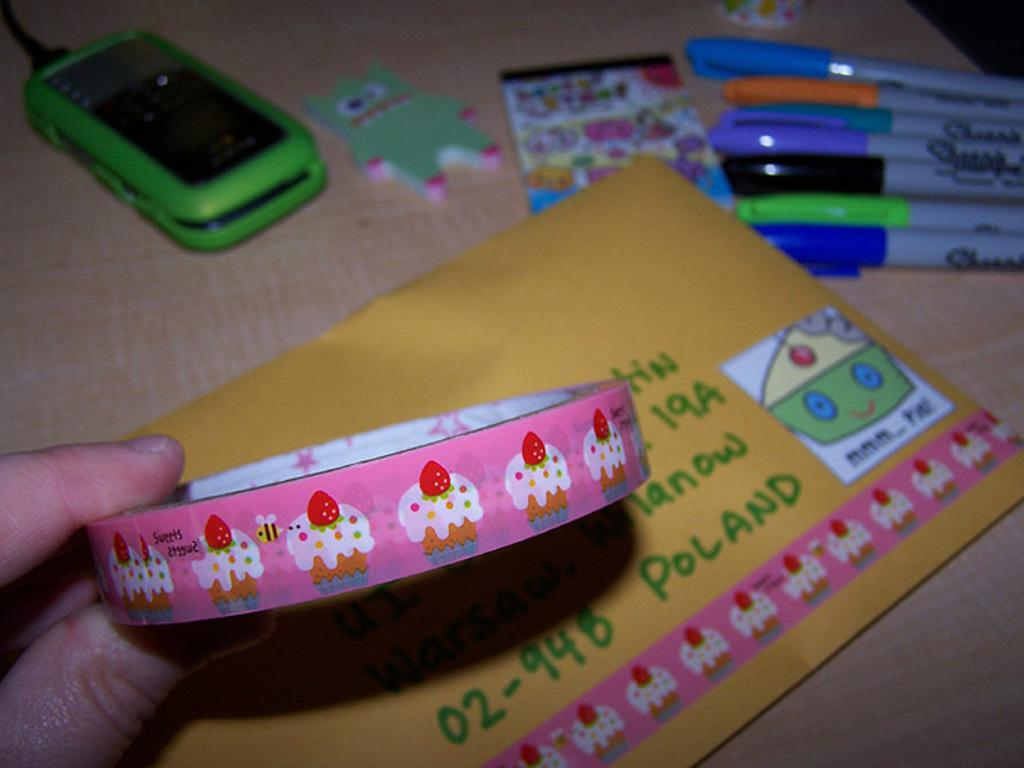<image>
Write a terse but informative summary of the picture. A roll of stickers that have been applied to an envelope going to Portland. 